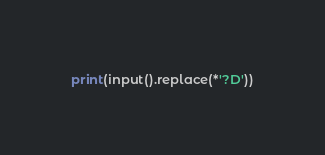<code> <loc_0><loc_0><loc_500><loc_500><_Cython_>print(input().replace(*'?D'))</code> 